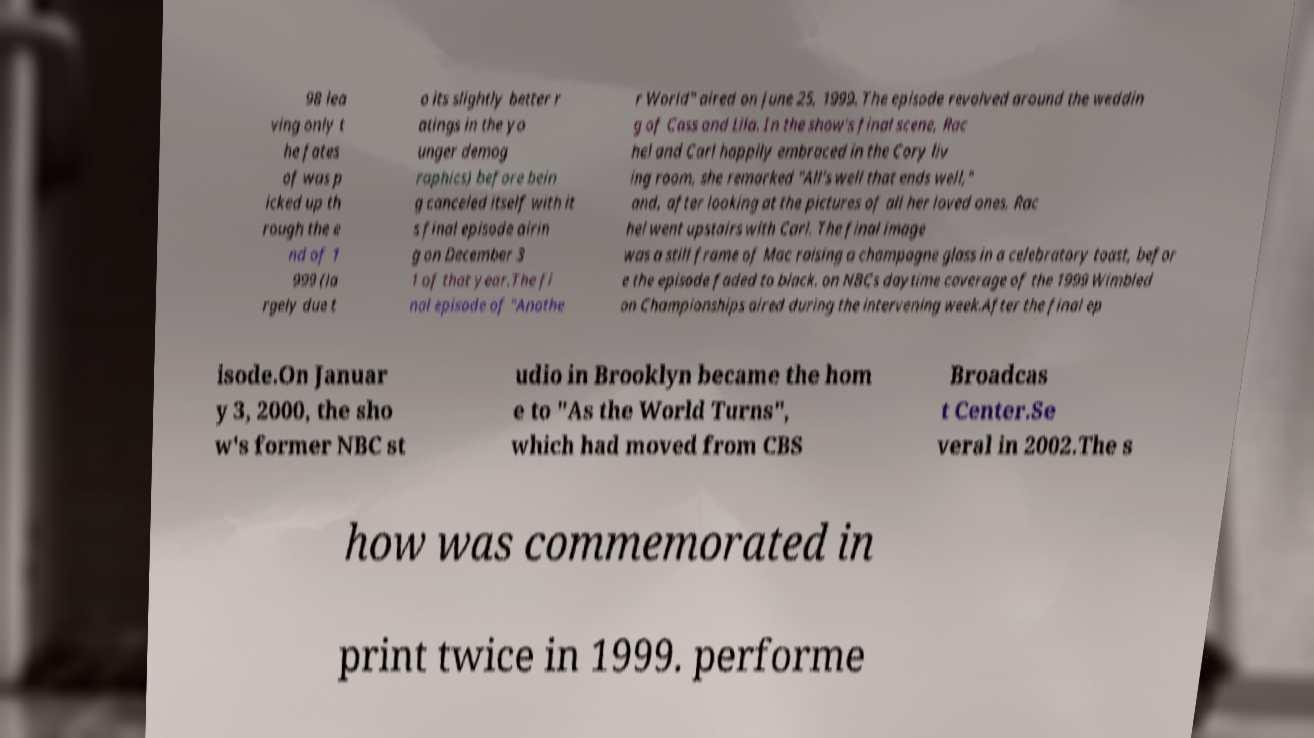Could you assist in decoding the text presented in this image and type it out clearly? 98 lea ving only t he fates of was p icked up th rough the e nd of 1 999 (la rgely due t o its slightly better r atings in the yo unger demog raphics) before bein g canceled itself with it s final episode airin g on December 3 1 of that year.The fi nal episode of "Anothe r World" aired on June 25, 1999. The episode revolved around the weddin g of Cass and Lila. In the show's final scene, Rac hel and Carl happily embraced in the Cory liv ing room, she remarked "All's well that ends well," and, after looking at the pictures of all her loved ones, Rac hel went upstairs with Carl. The final image was a still frame of Mac raising a champagne glass in a celebratory toast, befor e the episode faded to black. on NBCs daytime coverage of the 1999 Wimbled on Championships aired during the intervening week.After the final ep isode.On Januar y 3, 2000, the sho w's former NBC st udio in Brooklyn became the hom e to "As the World Turns", which had moved from CBS Broadcas t Center.Se veral in 2002.The s how was commemorated in print twice in 1999. performe 